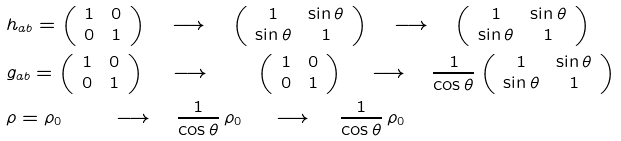<formula> <loc_0><loc_0><loc_500><loc_500>& \quad \, h _ { a b } = \left ( \begin{array} { c c } 1 & 0 \\ 0 & 1 \\ \end{array} \right ) \quad \longrightarrow \quad \left ( \begin{array} { c c } 1 & \sin \theta \\ \sin \theta & 1 \\ \end{array} \right ) \quad \longrightarrow \quad \left ( \begin{array} { c c } 1 & \sin \theta \\ \sin \theta & 1 \\ \end{array} \right ) \\ & \quad \, g _ { a b } = \left ( \begin{array} { c c } 1 & 0 \\ 0 & 1 \\ \end{array} \right ) \quad \, \longrightarrow \quad \, \quad \left ( \begin{array} { c c } 1 & 0 \\ 0 & 1 \\ \end{array} \right ) \quad \, \longrightarrow \quad \frac { 1 } { \cos \theta } \left ( \begin{array} { c c } 1 & \sin \theta \\ \sin \theta & 1 \\ \end{array} \right ) \\ & \quad \, \rho = \rho _ { 0 } \quad \, \quad \, \longrightarrow \quad \frac { 1 } { \cos \theta } \, \rho _ { 0 } \, \quad \, \longrightarrow \quad \, \frac { 1 } { \cos \theta } \, \rho _ { 0 }</formula> 